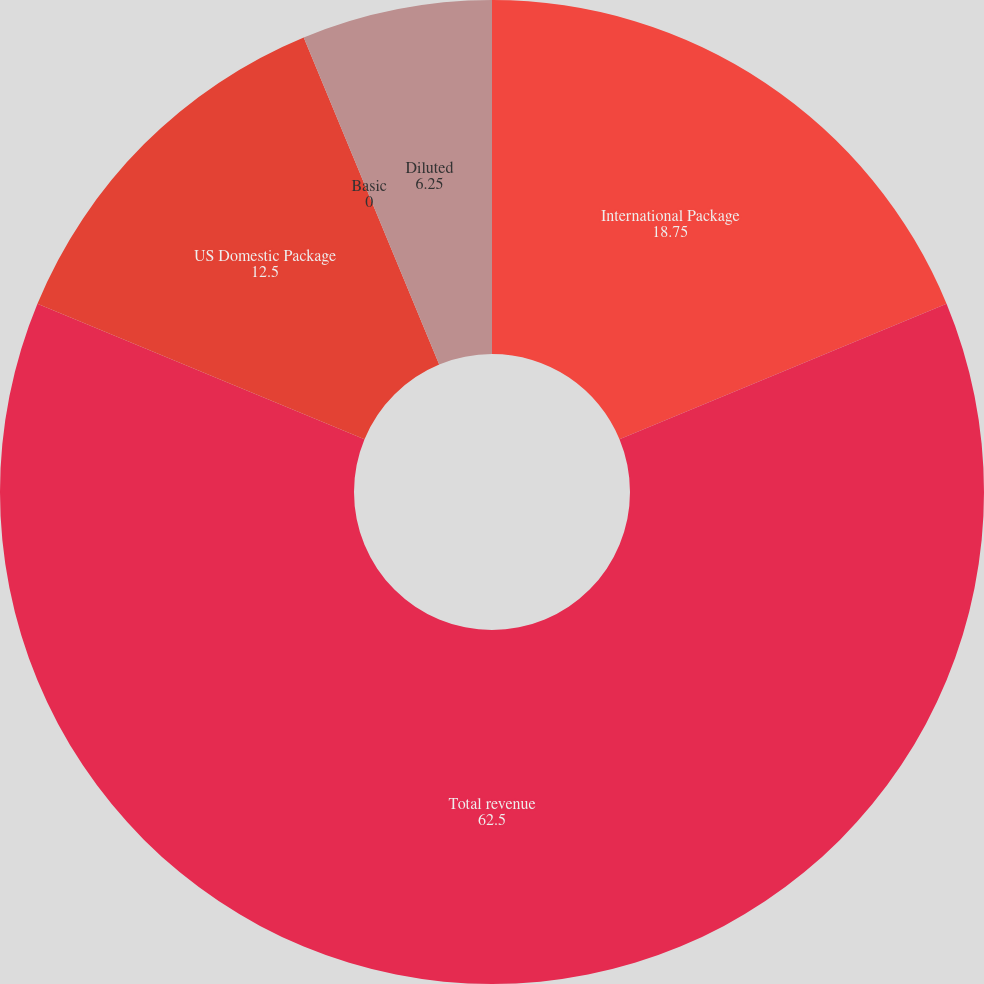Convert chart. <chart><loc_0><loc_0><loc_500><loc_500><pie_chart><fcel>International Package<fcel>Total revenue<fcel>US Domestic Package<fcel>Basic<fcel>Diluted<nl><fcel>18.75%<fcel>62.5%<fcel>12.5%<fcel>0.0%<fcel>6.25%<nl></chart> 